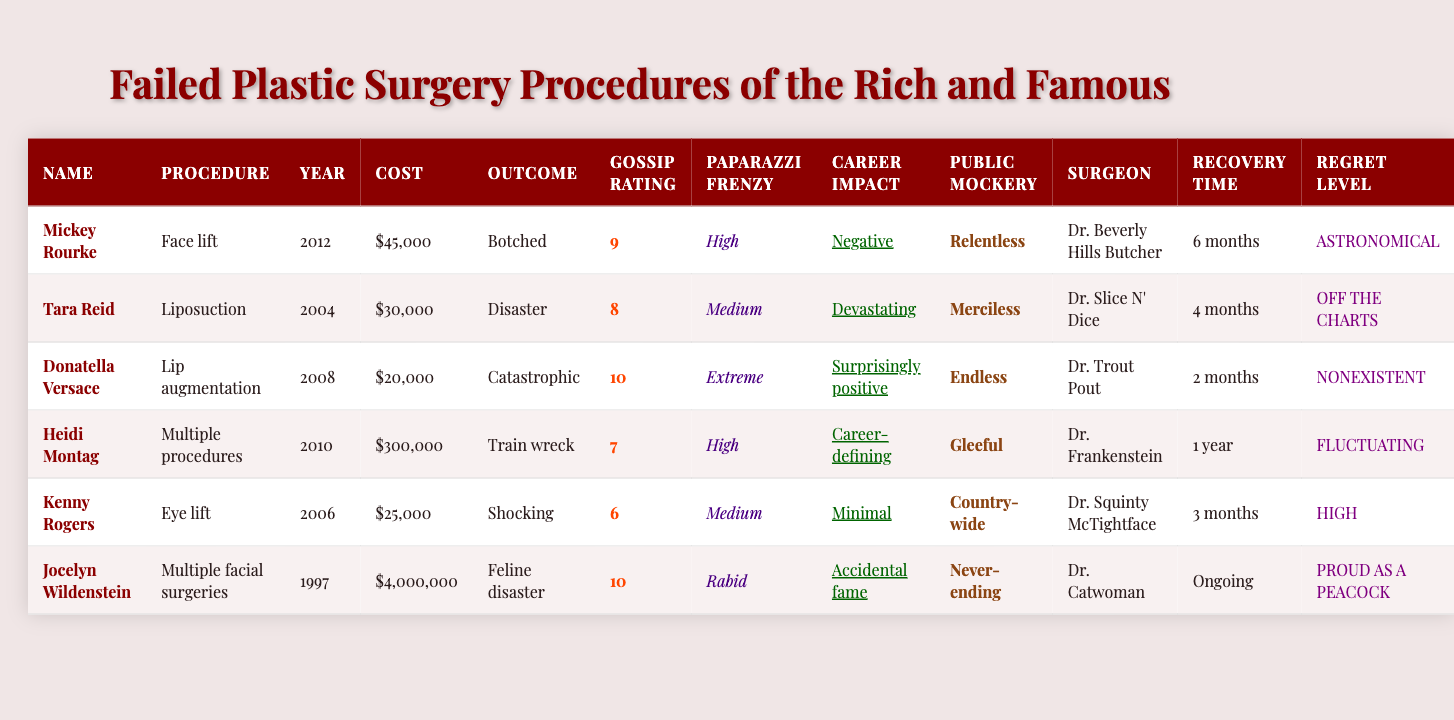What was the most expensive procedure listed in the table? The table shows that Jocelyn Wildenstein's multiple facial surgeries cost $4,000,000, which is higher than any other procedure listed.
Answer: $4,000,000 Which celebrity had the highest gossip rating? According to the table, Donatella Versace has the highest gossip rating at 10.
Answer: 10 Is it true that Mickey Rourke's surgery had a positive career impact? The table indicates that Mickey Rourke experienced a negative career impact from his face lift, making the statement false.
Answer: No What is the average cost of the procedures listed? The total cost of the procedures is $45,000 + $30,000 + $20,000 + $300,000 + $25,000 + $4,000,000 = $4,420,000. There are 6 procedures, so the average is $4,420,000 / 6 = $736,666.67.
Answer: $736,666.67 Which procedure had the longest recovery time? Heidi Montag's multiple procedures required a recovery time of 1 year, which is longer than the other listed procedures.
Answer: 1 year Which celebrity experienced relentless public mockery? The table states that Mickey Rourke endured relentless public mockery following his face lift.
Answer: Mickey Rourke Are all procedures listed by a surgeon named "Dr. Slice N' Dice"? The table clearly mentions that only Tara Reid's liposuction was performed by Dr. Slice N' Dice, so the answer is false.
Answer: No Which celebrity had the most disastrous outcome and how much did it cost? Tara Reid had a disastrous outcome for her liposuction, costing $30,000.
Answer: Tara Reid, $30,000 What percentage of the total costs is linked to Jocelyn Wildenstein’s surgery? The total cost is $4,420,000 and Jocelyn Wildenstein's surgery cost $4,000,000. Therefore,  ($4,000,000 / $4,420,000) * 100 = 90.5%.
Answer: 90.5% Out of the surgeries, which one had a surprisingly positive career impact? Donatella Versace's lip augmentation is the only procedure that reports a surprisingly positive career impact.
Answer: Donatella Versace Did any of the celebrities exhibit a complete lack of regret after their procedure? Yes, according to the table, Donatella Versace reported a "nonexistent" level of regret regarding her lip augmentation.
Answer: Yes 